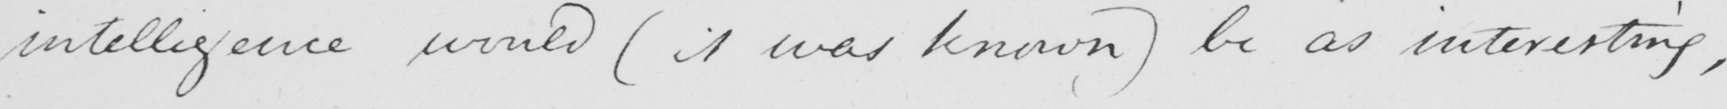Transcribe the text shown in this historical manuscript line. intelligence would  ( it was known )  be as interesting , 